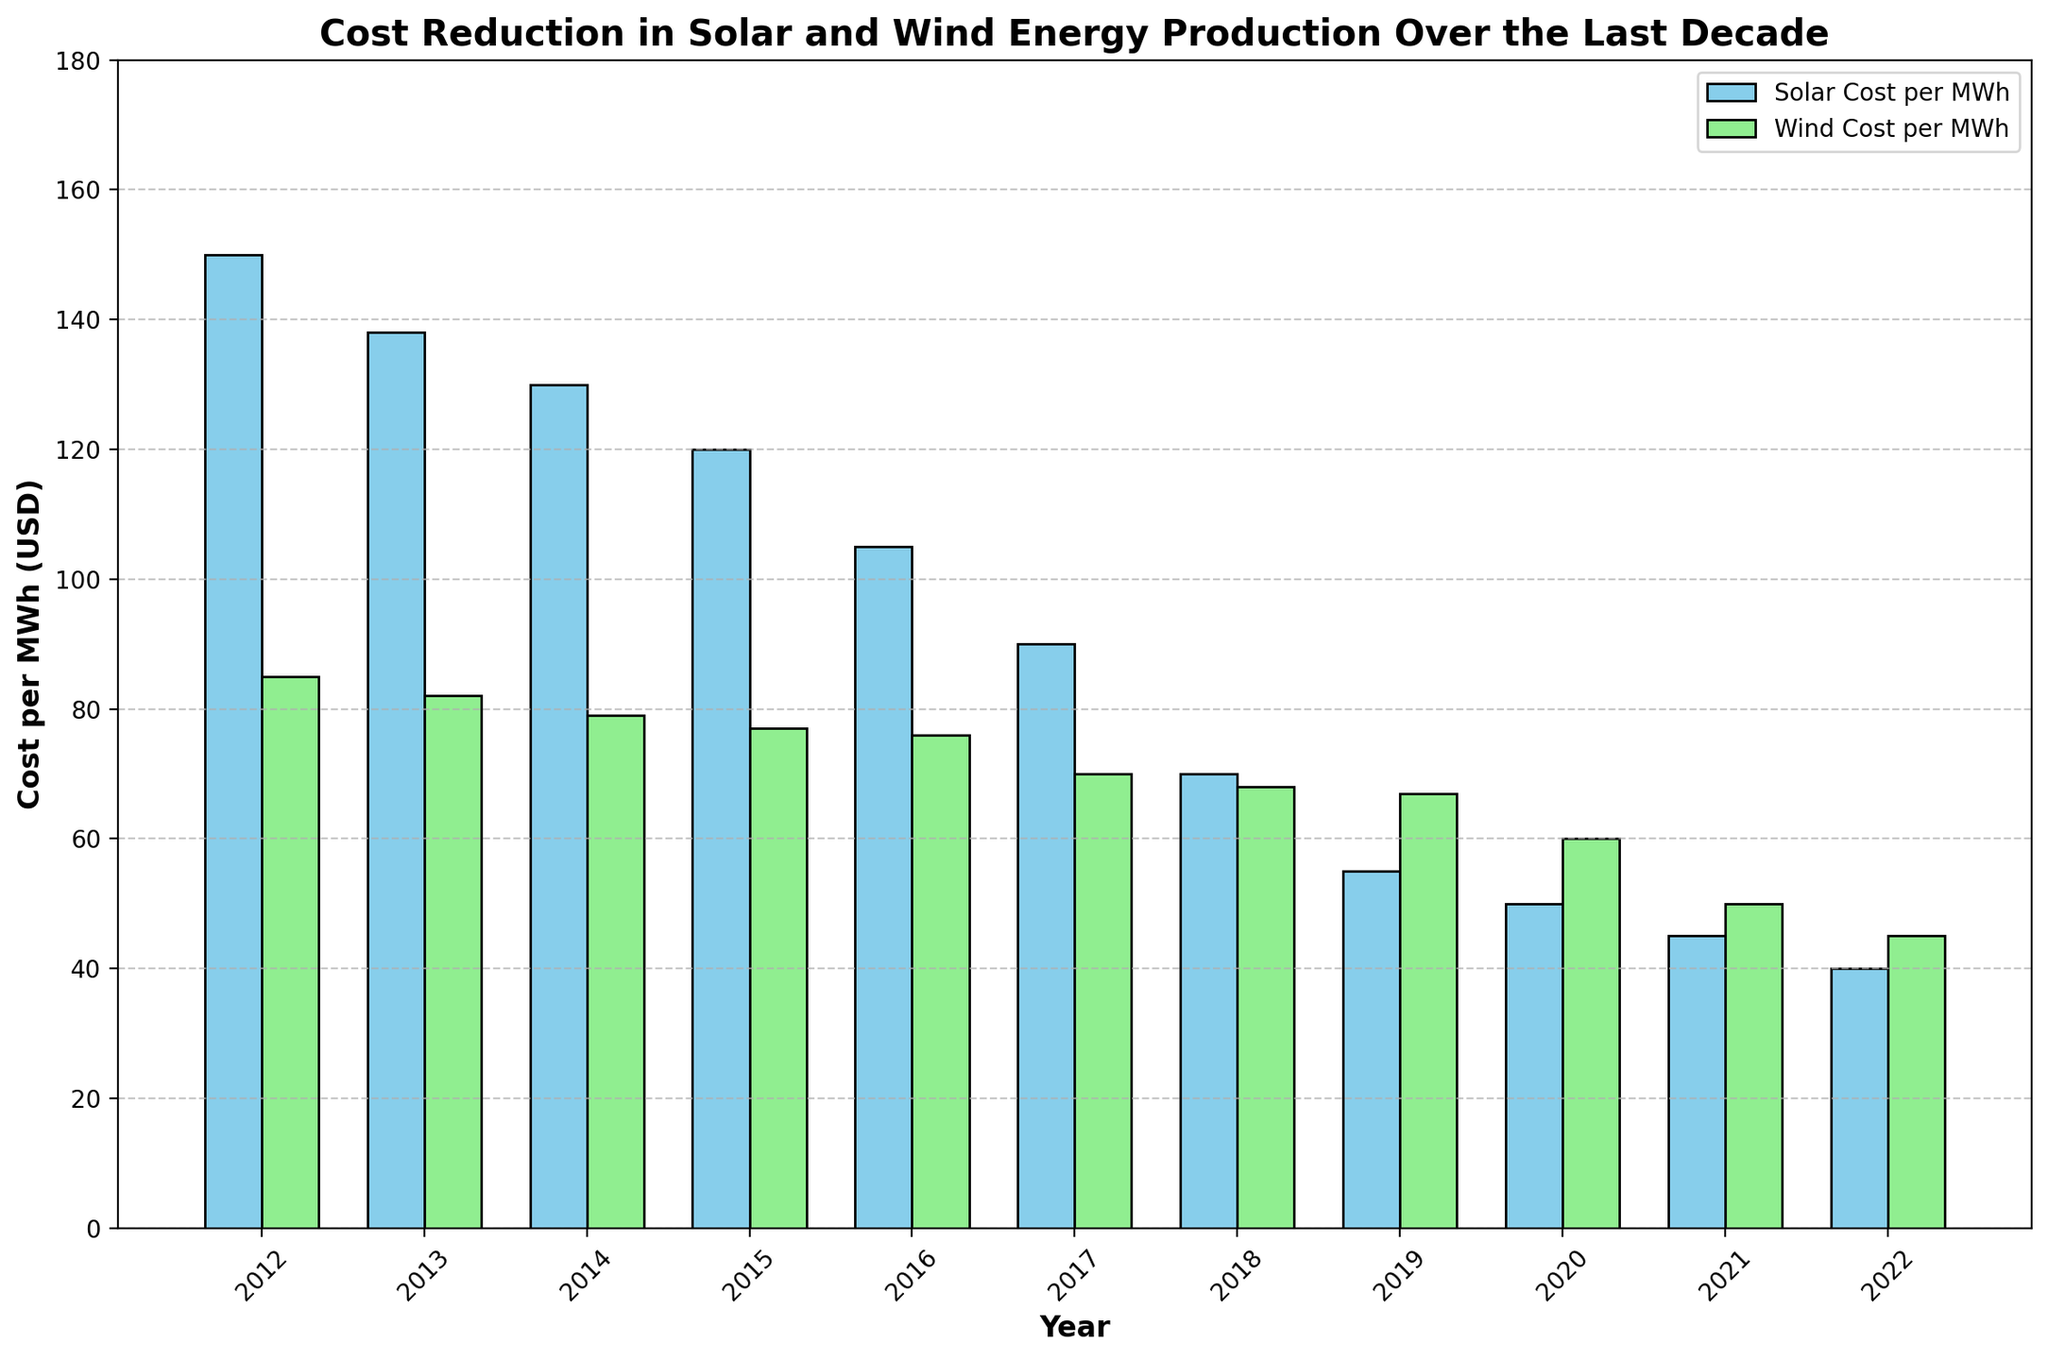What year saw the lowest cost per MWh for solar energy? Looking at the blue bars representing solar energy costs, the smallest bar indicates the lowest cost. The year labeled below this bar is 2022.
Answer: 2022 What was the decrease in the cost per MWh for wind energy from 2012 to 2022? The height of the green bar in 2012 represents 85 USD, and in 2022, it's 45 USD. The decrease is 85 - 45 = 40 USD.
Answer: 40 USD In which year did solar energy costs fall below 100 USD per MWh for the first time? Observing the blue bars, the first one below the 100 mark on the y-axis corresponds to 2016.
Answer: 2016 How did the costs of solar and wind energy compare in 2017? In 2017, the height of the blue bar (solar) is 90 USD and the green bar (wind) is 70 USD. So, solar costs were 20 USD more than wind costs.
Answer: Solar was 20 USD higher than wind On average, how much did the cost per MWh for solar energy decrease each year over the decade? To find the average annual decrease: (initial cost - final cost) / number of years = (150 - 40) / (2022 - 2012) = 110 / 10 = 11 USD/year.
Answer: 11 USD/year Which year saw the greatest cost decline for solar energy compared to the previous year? By examining the differences between consecutive blue bars: 2017-2016: 90-105=15; 2018-2017: 70-90=20; 2019-2018: 55-70=15; 2020-2019: 50-55=5; the largest decrease is in 2018 compared to 2017, which is 20 USD.
Answer: 2018 Visualizing the trend, which energy type had a more consistent decrease in cost over the decade? While both trends show a decrease, the blue bars (solar energy) show a steady decline each year, unlike the green bars (wind energy), which show more variability.
Answer: Solar energy What is the combined cost of solar and wind energy per MWh in 2020? In 2020, the solar cost is 50 USD and the wind cost is 60 USD. Combined, it's 50 + 60 = 110 USD.
Answer: 110 USD Which year had a greater reduction in solar costs relative to wind by more than 20 USD compared to the previous year? Comparing year-over-year changes: in 2018 solar dropped by 20 USD (90-70) while wind dropped by only 2 USD (70-68). Thus, 2018 is the year where solar decreased by more than 20 USD relative to wind.
Answer: 2018 